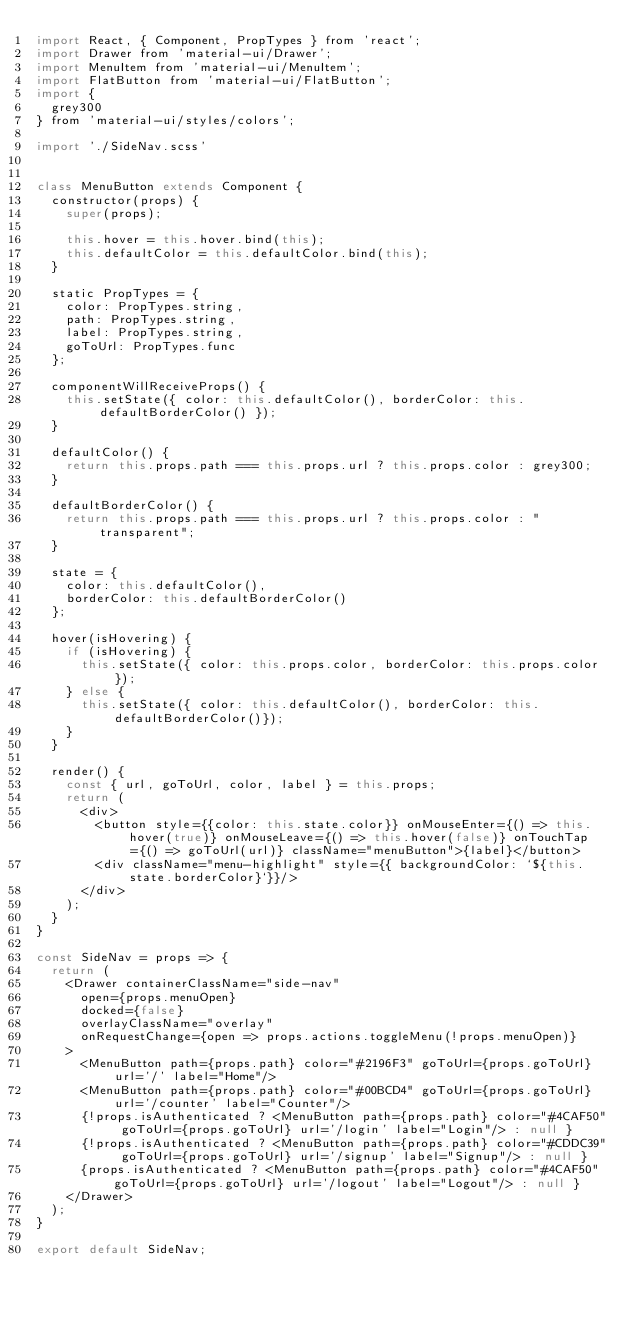Convert code to text. <code><loc_0><loc_0><loc_500><loc_500><_JavaScript_>import React, { Component, PropTypes } from 'react';
import Drawer from 'material-ui/Drawer';
import MenuItem from 'material-ui/MenuItem';
import FlatButton from 'material-ui/FlatButton';
import {
  grey300
} from 'material-ui/styles/colors';

import './SideNav.scss'


class MenuButton extends Component {
  constructor(props) {
    super(props);

    this.hover = this.hover.bind(this);
    this.defaultColor = this.defaultColor.bind(this);
  }

  static PropTypes = {
    color: PropTypes.string,
    path: PropTypes.string,
    label: PropTypes.string,
    goToUrl: PropTypes.func
  };

  componentWillReceiveProps() {
    this.setState({ color: this.defaultColor(), borderColor: this.defaultBorderColor() });
  }

  defaultColor() {
    return this.props.path === this.props.url ? this.props.color : grey300;
  }

  defaultBorderColor() {
    return this.props.path === this.props.url ? this.props.color : "transparent";
  }

  state = {
    color: this.defaultColor(),
    borderColor: this.defaultBorderColor()
  };

  hover(isHovering) {
    if (isHovering) {
      this.setState({ color: this.props.color, borderColor: this.props.color});
    } else {
      this.setState({ color: this.defaultColor(), borderColor: this.defaultBorderColor()});
    }
  }

  render() {
    const { url, goToUrl, color, label } = this.props;
    return (
      <div>
        <button style={{color: this.state.color}} onMouseEnter={() => this.hover(true)} onMouseLeave={() => this.hover(false)} onTouchTap={() => goToUrl(url)} className="menuButton">{label}</button>
        <div className="menu-highlight" style={{ backgroundColor: `${this.state.borderColor}`}}/>
      </div>
    );
  }
}

const SideNav = props => {
  return (
    <Drawer containerClassName="side-nav"
      open={props.menuOpen}
      docked={false}
      overlayClassName="overlay"
      onRequestChange={open => props.actions.toggleMenu(!props.menuOpen)}
    >
      <MenuButton path={props.path} color="#2196F3" goToUrl={props.goToUrl} url='/' label="Home"/>
      <MenuButton path={props.path} color="#00BCD4" goToUrl={props.goToUrl} url='/counter' label="Counter"/>
      {!props.isAuthenticated ? <MenuButton path={props.path} color="#4CAF50" goToUrl={props.goToUrl} url='/login' label="Login"/> : null }
      {!props.isAuthenticated ? <MenuButton path={props.path} color="#CDDC39" goToUrl={props.goToUrl} url='/signup' label="Signup"/> : null }
      {props.isAuthenticated ? <MenuButton path={props.path} color="#4CAF50" goToUrl={props.goToUrl} url='/logout' label="Logout"/> : null }
    </Drawer>
  );
}

export default SideNav;
</code> 